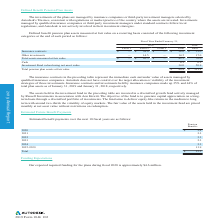According to Autodesk's financial document, Who manages Autodesk's pension plans? The investments of the plans are managed by insurance companies or third-party investment managers selected by Autodesk's Trustees, consistent with regulations or market practice of the country where the assets are invested.. The document states: "The investments of the plans are managed by insurance companies or third-party investment managers selected by Autodesk's Trustees, consistent with re..." Also, Where are the assets in the investment fund in the preceding table held? The assets held in the investment fund in the preceding table are invested in a diversified growth fund actively managed by Russell Investments in association with Aon Hewitt. The document states: "The assets held in the investment fund in the preceding table are invested in a diversified growth fund actively managed by Russell Investments in ass..." Also, How are the assets in the investment fund priced? The fair value of the assets held in the investment fund are priced monthly at net asset value without restrictions on redemption.. The document states: "round two-thirds the volatility of equity markets. The fair value of the assets held in the investment fund are priced monthly at net asset value with..." Also, can you calculate: What is the percentage change in total assets measured at fair value from 2018 to 2019? To answer this question, I need to perform calculations using the financial data. The calculation is: ((42.5-70)/70), which equals -39.29 (percentage). This is based on the information: "assets measured at fair value $ — $ 42.5 $ — 42.5 70.0 Cash 4.3 0.2 Investment Fund valued using net asset value 34.0 50.9 Total pension plan assets at .5 17.0 Total assets measured at fair value $ — ..." The key data points involved are: 42.5, 70. Also, can you calculate: How much of the total plan assets comprises cash in 2019? Based on the calculation: (4.3/80.8), the result is 5.32 (percentage). This is based on the information: ".0 50.9 Total pension plan assets at fair value $ 80.8 $ 121.1 sured at fair value $ — $ 42.5 $ — 42.5 70.0 Cash 4.3 0.2 Investment Fund valued using net asset value 34.0 50.9 Total pension plan asset..." The key data points involved are: 4.3, 80.8. Also, can you calculate: What is the percentage change in insurance contracts between 2018 and 2019? To answer this question, I need to perform calculations using the financial data. The calculation is: (28-53)/53 , which equals -47.17 (percentage). This is based on the information: "l 2 Level 3 Total Total Insurance contracts $ — $ 28.0 $ — $ 28.0 $ 53.0 Other investments — 14.5 — 14.5 17.0 Total assets measured at fair value $ — $ Total Insurance contracts $ — $ 28.0 $ — $ 28.0 ..." The key data points involved are: 28, 53. 